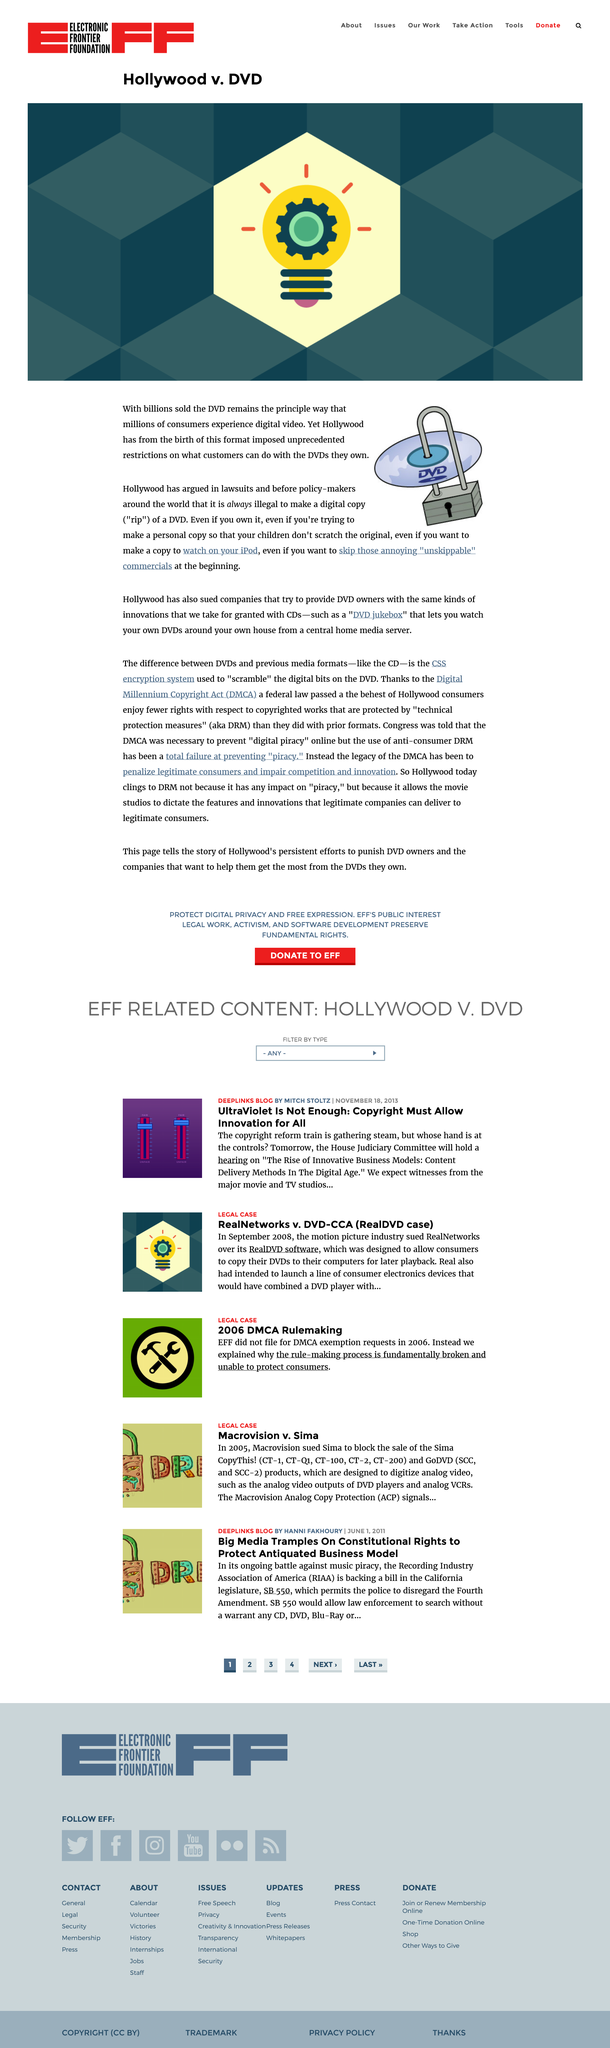Indicate a few pertinent items in this graphic. The image depicts a padlock being used to secure a DVD. Billions of DVDs have been sold, indicating the widespread popularity and success of the product. Hollywood has imposed unprecedented restrictions on customers copying DVDs and has argued in lawsuits about this issue. 